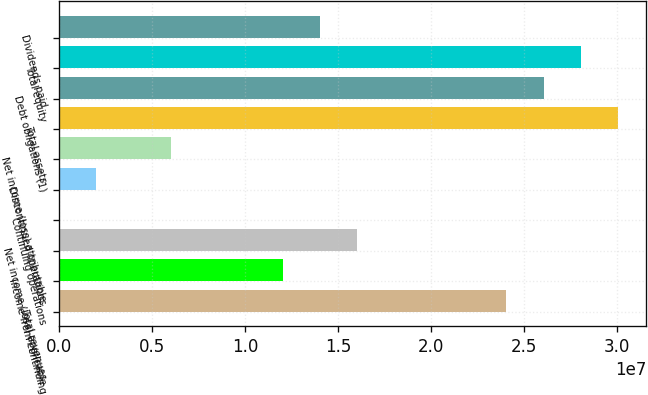Convert chart to OTSL. <chart><loc_0><loc_0><loc_500><loc_500><bar_chart><fcel>Total revenues<fcel>Income from continuing<fcel>Net income (loss) applicable<fcel>Continuing operations<fcel>Discontinued operations<fcel>Net income (loss) attributable<fcel>Total assets<fcel>Debt obligations (1)<fcel>Total equity<fcel>Dividends paid<nl><fcel>2.40484e+07<fcel>1.20242e+07<fcel>1.60322e+07<fcel>0.52<fcel>2.00403e+06<fcel>6.01209e+06<fcel>3.00605e+07<fcel>2.60524e+07<fcel>2.80564e+07<fcel>1.40282e+07<nl></chart> 